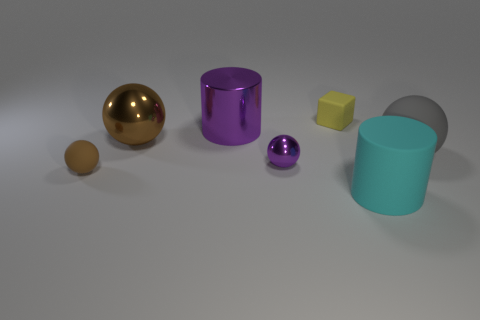Is there any other thing that has the same shape as the small yellow matte thing?
Keep it short and to the point. No. There is a purple thing that is behind the matte sphere to the right of the large cyan thing; what number of big matte balls are on the left side of it?
Your answer should be compact. 0. What material is the thing that is both on the left side of the gray ball and on the right side of the yellow block?
Provide a succinct answer. Rubber. What color is the big thing that is behind the tiny metal object and right of the tiny purple thing?
Provide a short and direct response. Gray. Is there any other thing that is the same color as the block?
Your answer should be compact. No. The rubber object on the left side of the tiny rubber object that is behind the matte ball left of the big brown sphere is what shape?
Make the answer very short. Sphere. The other rubber thing that is the same shape as the brown matte thing is what color?
Your response must be concise. Gray. What color is the tiny rubber object that is on the right side of the big cylinder that is left of the yellow object?
Provide a short and direct response. Yellow. The brown matte thing that is the same shape as the tiny metallic thing is what size?
Your answer should be compact. Small. What number of big purple cylinders have the same material as the yellow block?
Your response must be concise. 0. 